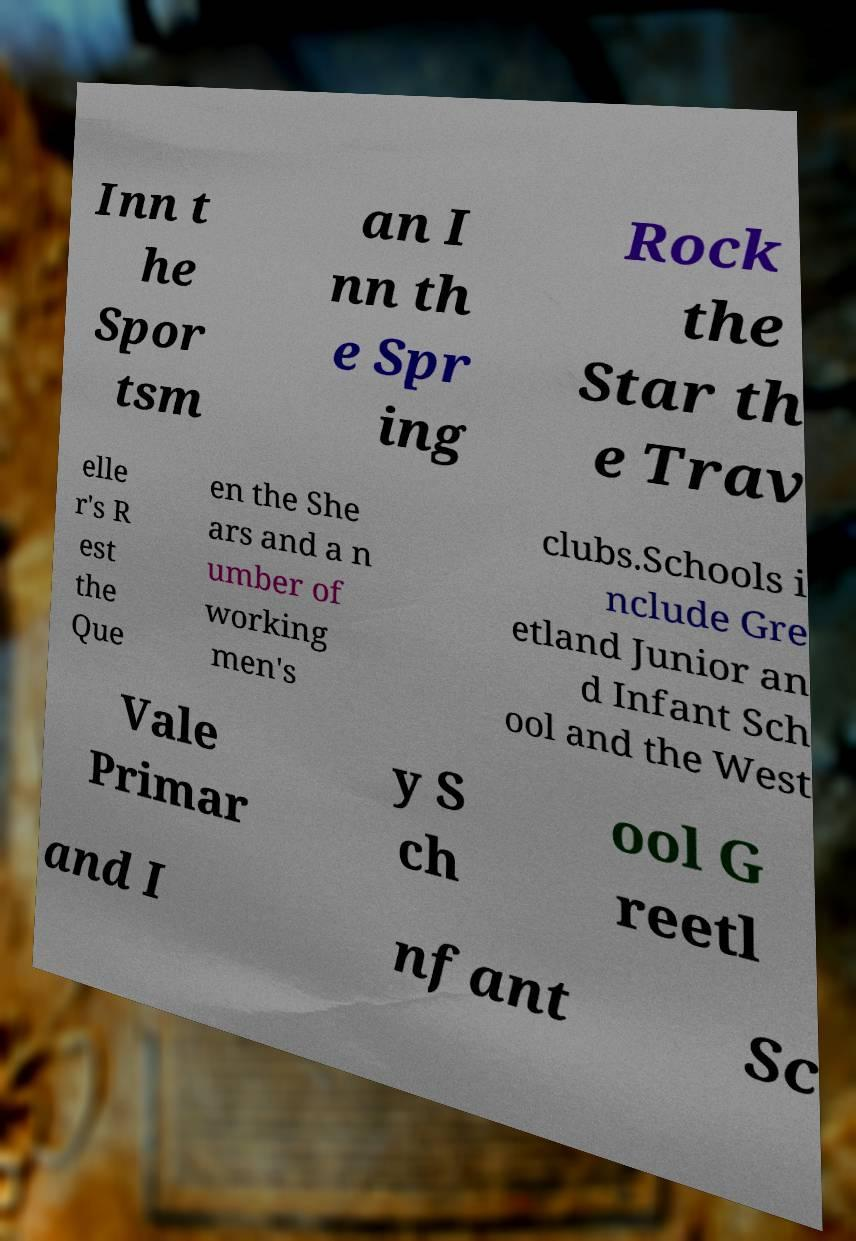Can you read and provide the text displayed in the image?This photo seems to have some interesting text. Can you extract and type it out for me? Inn t he Spor tsm an I nn th e Spr ing Rock the Star th e Trav elle r's R est the Que en the She ars and a n umber of working men's clubs.Schools i nclude Gre etland Junior an d Infant Sch ool and the West Vale Primar y S ch ool G reetl and I nfant Sc 